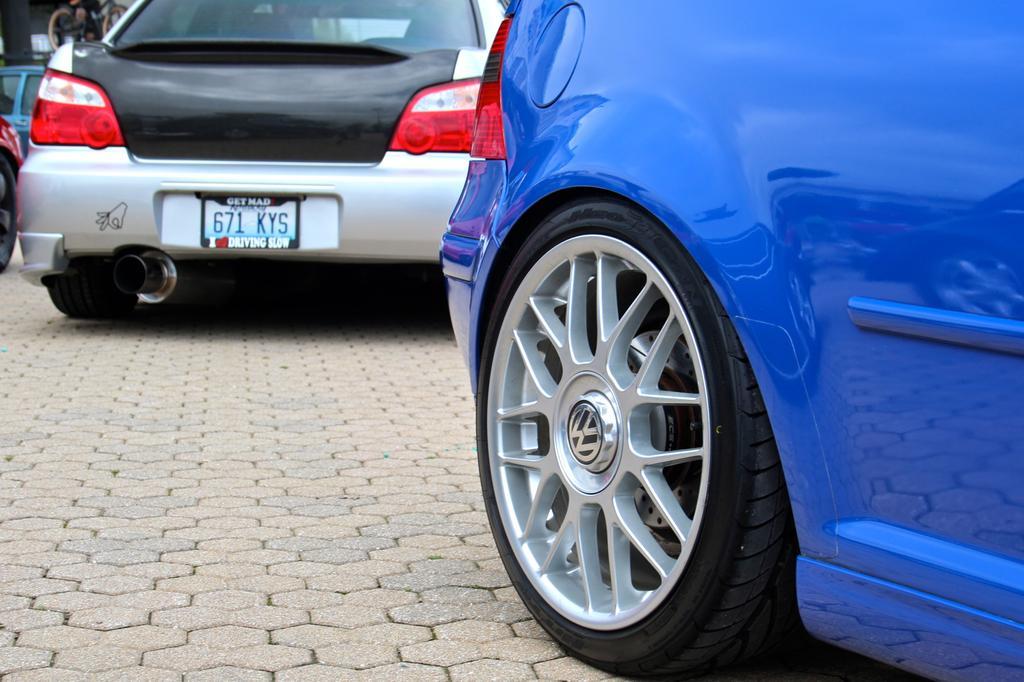Describe this image in one or two sentences. In the foreground of the image we can see a platform and the blue color car and a tire. On the top of the image we can see a black and silver color car. 